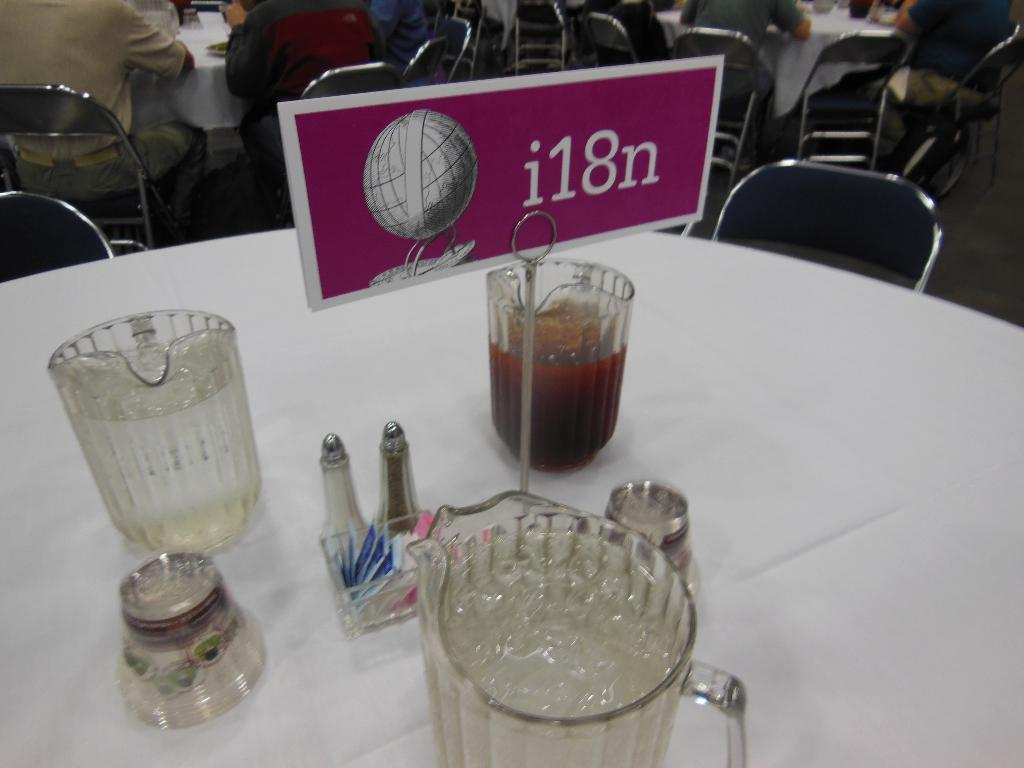<image>
Relay a brief, clear account of the picture shown. A table has three pitchers of assorted drinks and a sign that says i18n. 